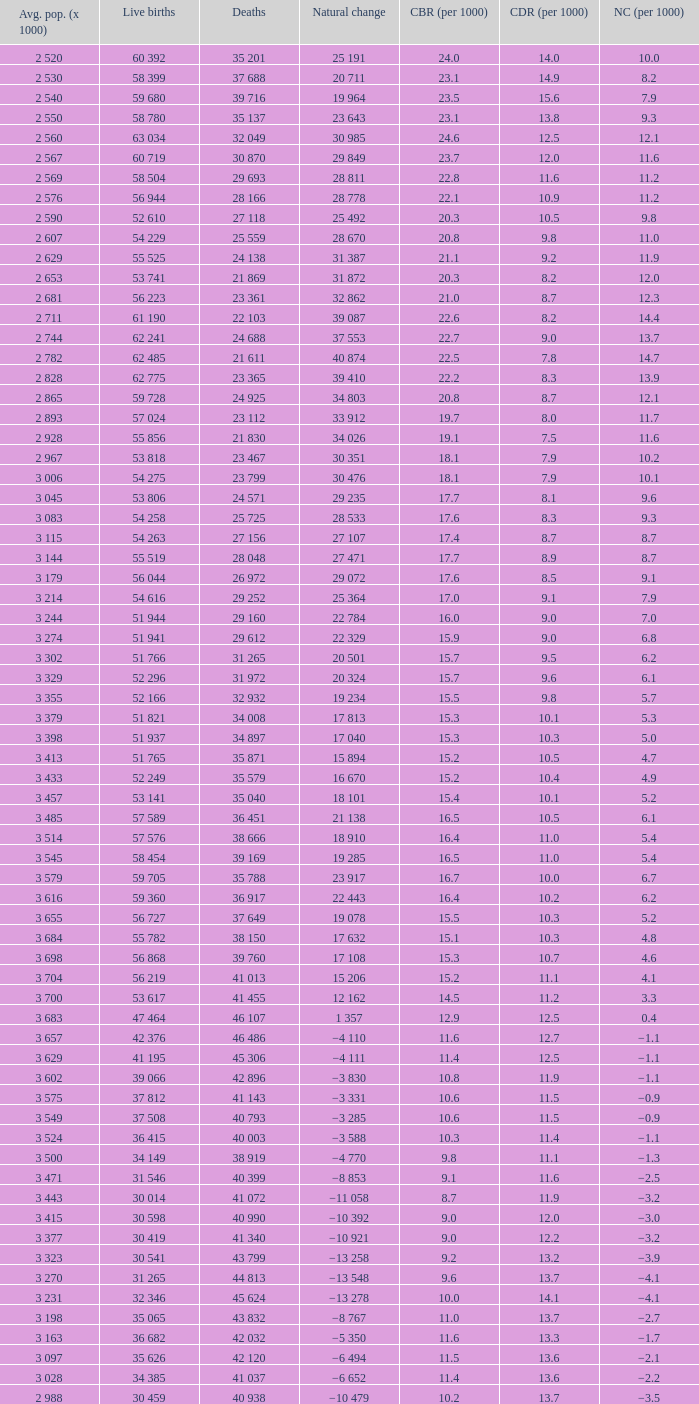Which Live births have a Natural change (per 1000) of 12.0? 53 741. 